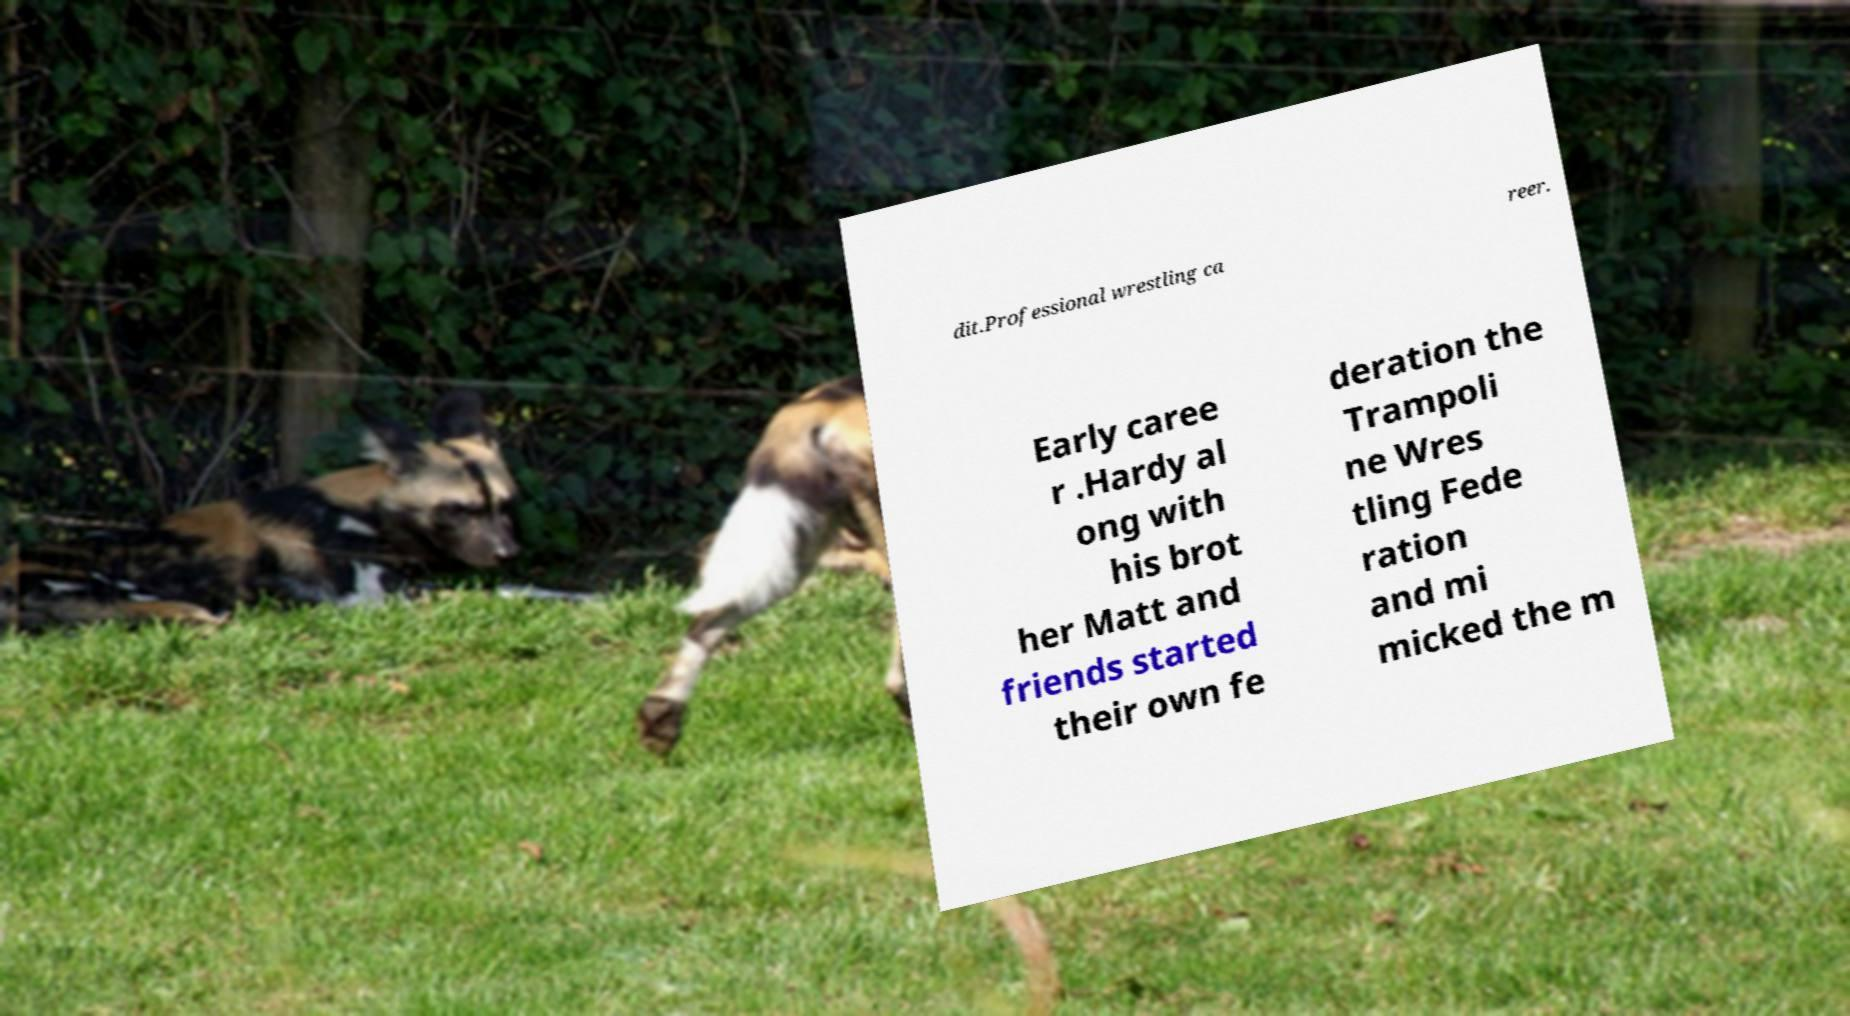Could you assist in decoding the text presented in this image and type it out clearly? dit.Professional wrestling ca reer. Early caree r .Hardy al ong with his brot her Matt and friends started their own fe deration the Trampoli ne Wres tling Fede ration and mi micked the m 